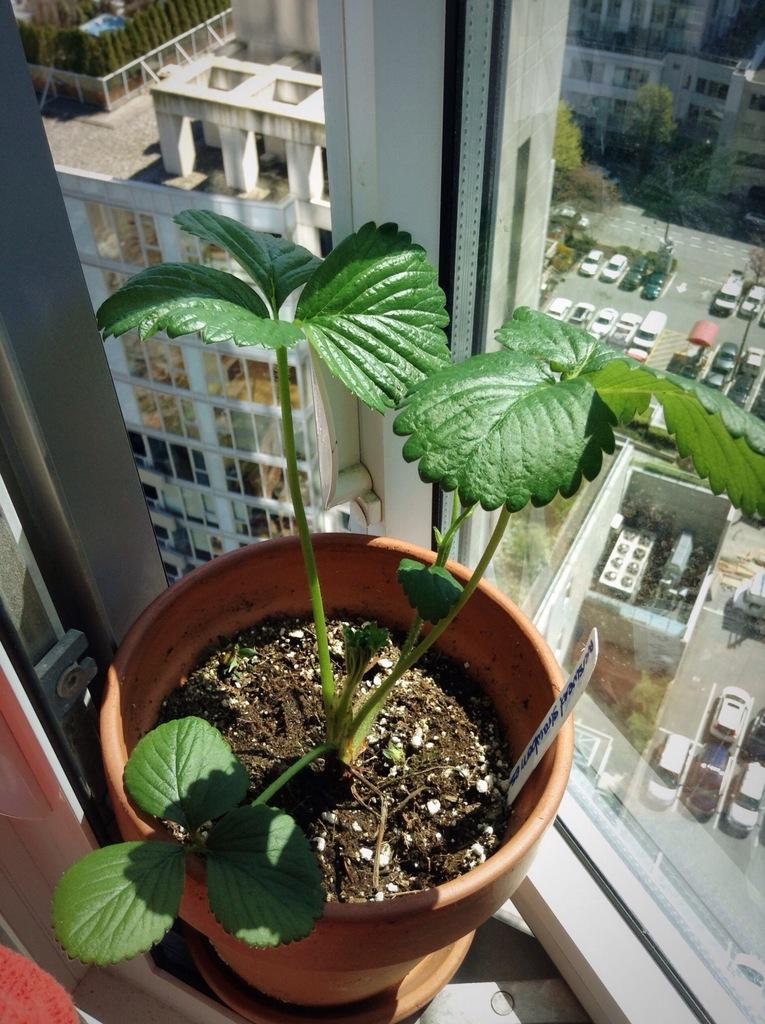What object is present in the image? There is a pot in the image. What architectural feature is visible in the image? There is a window in the image. What can be seen through the window? Many vehicles, trees, and buildings are visible through the window. Who is the owner of the coil in the image? There is no coil present in the image, so it is not possible to determine the owner. 